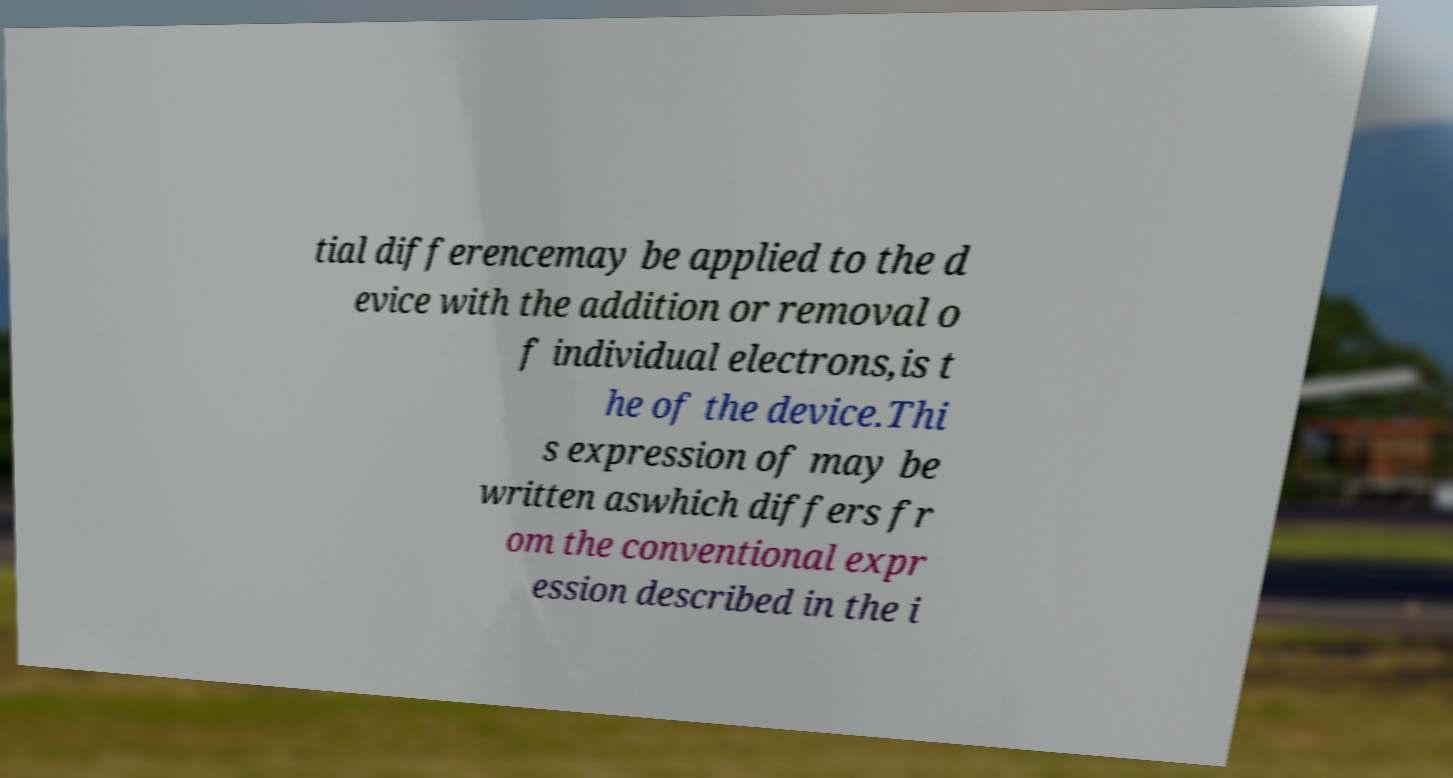Please identify and transcribe the text found in this image. tial differencemay be applied to the d evice with the addition or removal o f individual electrons,is t he of the device.Thi s expression of may be written aswhich differs fr om the conventional expr ession described in the i 